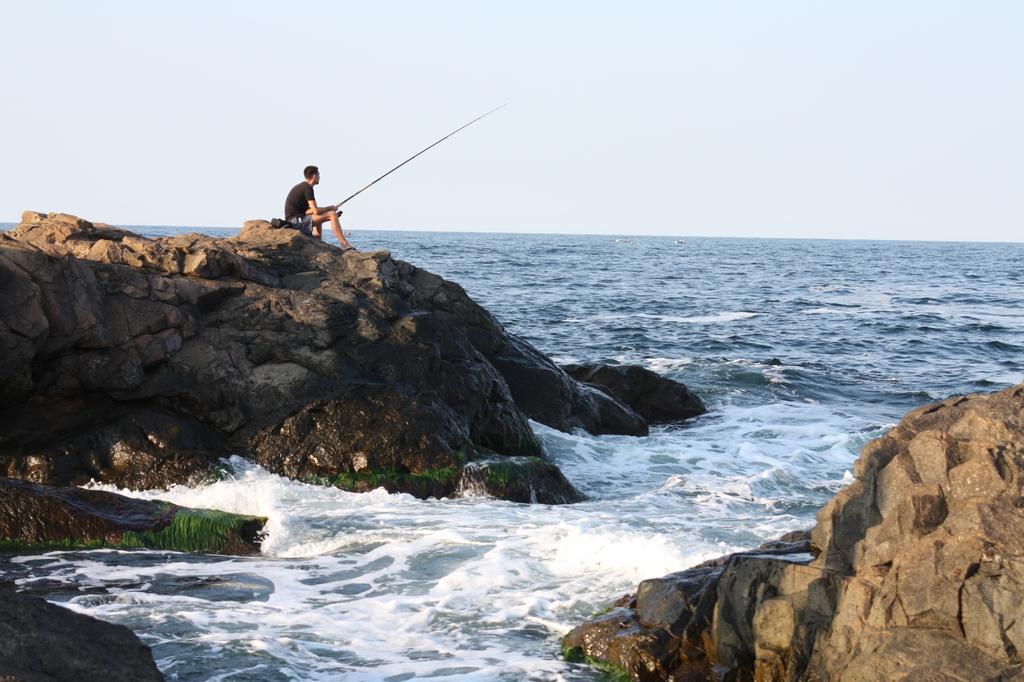In one or two sentences, can you explain what this image depicts? In this image I can see water in the front and in the background of this image. I can also see few rocks on the both side and on the left side of this image I can see one person is sitting. I can see he is holding a stick. 